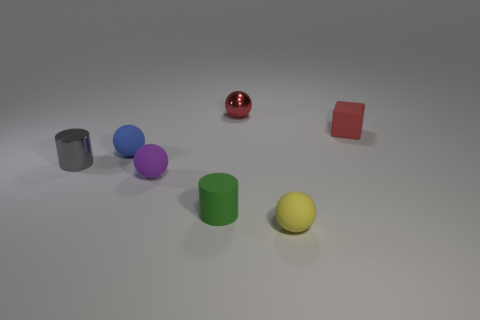How many other things are the same shape as the purple thing?
Provide a short and direct response. 3. There is a small yellow sphere that is in front of the small matte object that is right of the small yellow matte ball; what is its material?
Offer a terse response. Rubber. Are there any things on the left side of the green rubber thing?
Offer a very short reply. Yes. Does the gray shiny thing have the same size as the red object in front of the red ball?
Provide a short and direct response. Yes. There is a purple object that is the same shape as the blue matte object; what is its size?
Offer a very short reply. Small. Is there any other thing that has the same material as the blue ball?
Keep it short and to the point. Yes. There is a metallic thing that is on the left side of the tiny purple rubber thing; is it the same size as the thing that is behind the tiny rubber cube?
Give a very brief answer. Yes. What number of tiny things are either cylinders or blue rubber things?
Make the answer very short. 3. What number of objects are behind the gray cylinder and right of the blue thing?
Provide a succinct answer. 2. Does the small gray object have the same material as the cylinder that is in front of the gray shiny cylinder?
Make the answer very short. No. 